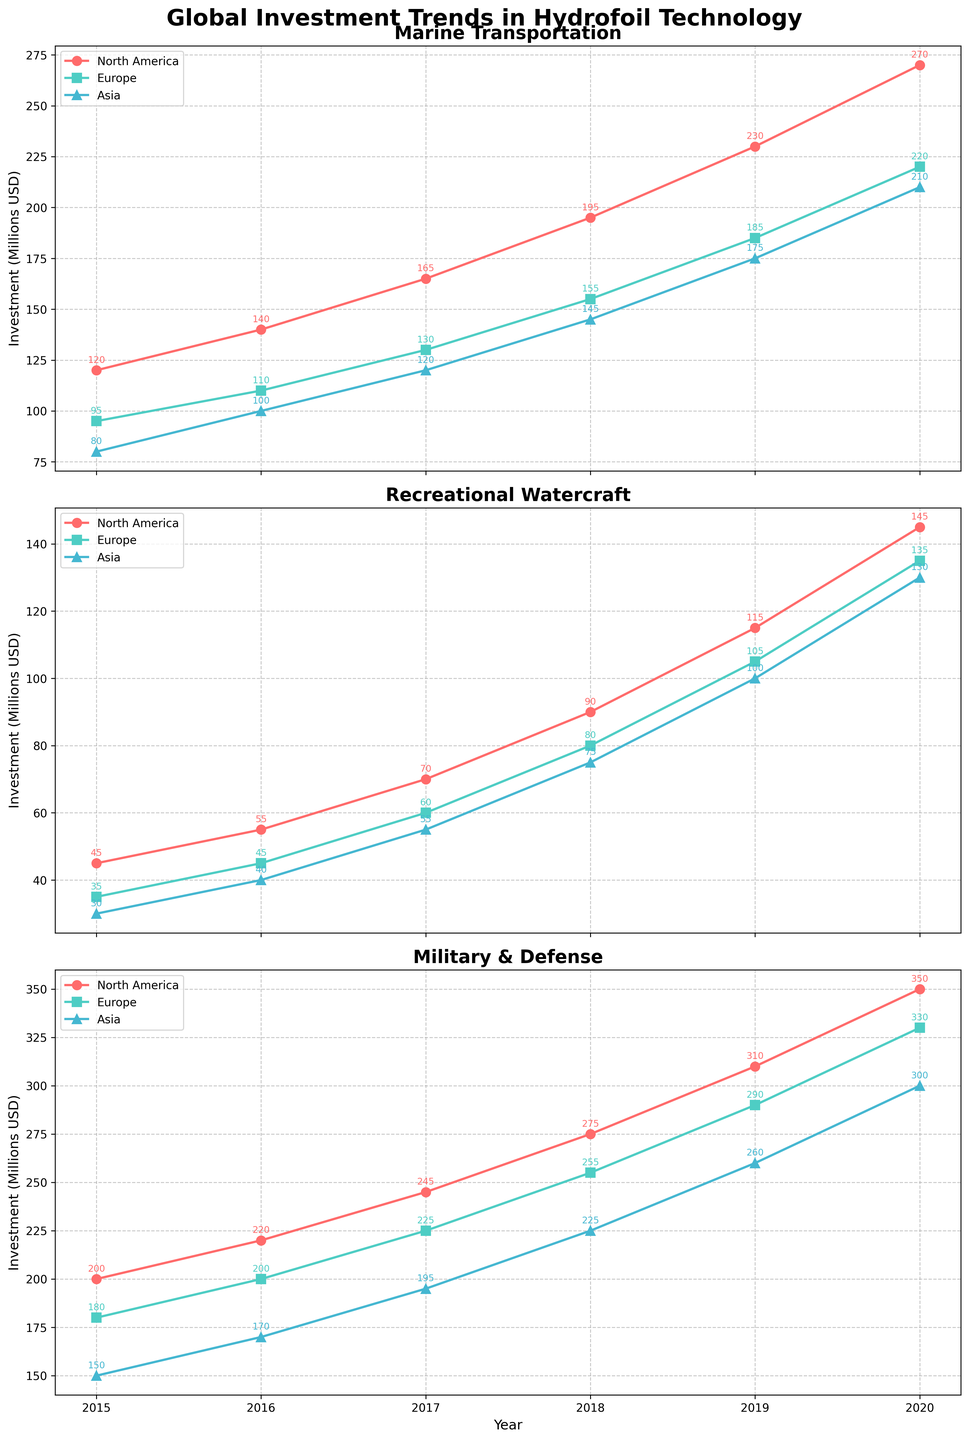What is the total investment in Marine Transportation for North America for all years? First, extract the investment values for North America in the Marine Transportation sector for all years. Sum these values: 120 (2015) + 140 (2016) + 165 (2017) + 195 (2018) + 230 (2019) + 270 (2020) = 1120 million USD.
Answer: 1120 million USD Which sector in Europe saw the highest investment in the year 2020? Identify the investment values for Europe in the year 2020 across all sectors: Marine Transportation (220), Recreational Watercraft (135), Military & Defense (330). The highest value among these is 330 million USD for the Military & Defense sector.
Answer: Military & Defense What was the trend in the Recreational Watercraft investment in Asia from 2015 to 2020? Analyze the yearly investment values for Asia in the Recreational Watercraft sector: 2015 (30), 2016 (40), 2017 (55), 2018 (75), 2019 (100), 2020 (130). The values show an increasing trend over the years.
Answer: Increasing By how much did the investment in Military & Defense for North America increase from 2015 to 2020? Compare the investment values for Military & Defense in North America for the years 2015 (200) and 2020 (350). The increase is calculated as 350 - 200 = 150 million USD.
Answer: 150 million USD Which region had the lowest investment in Recreational Watercraft in 2017? Examine the investment values for Recreational Watercraft in 2017 across all regions: North America (70), Europe (60), Asia (55). The lowest investment is in Asia with 55 million USD.
Answer: Asia What is the average annual investment in Military & Defense for Europe from 2015 to 2020? Extract the annual investment values in Military & Defense for Europe: 2015 (180), 2016 (200), 2017 (225), 2018 (255), 2019 (290), 2020 (330). Calculate the average: (180 + 200 + 225 + 255 + 290 + 330) / 6 = 246.67 million USD.
Answer: 246.67 million USD Which year did North America see the highest investment in Marine Transportation, and how much was it? Identify the investment values for Marine Transportation in North America across all years: 2015 (120), 2016 (140), 2017 (165), 2018 (195), 2019 (230), 2020 (270). The highest investment was in 2020 amounting to 270 million USD.
Answer: 2020, 270 million USD How does the investment in Marine Transportation in Asia in 2020 compare to that in Europe in the same year? Compare the investment values for Marine Transportation in Asia (210) and Europe (220) in 2020. Since 210 < 220, Asia's investment is lower than Europe's.
Answer: Asia's investment is lower What was the percentage increase in the investment in Military & Defense in Asia from 2017 to 2020? Compute the percentage increase from 2017 (195) to 2020 (300) as follows: [(300 - 195) / 195] * 100 = 53.85%.
Answer: 53.85% What is the total investment in Recreational Watercraft globally in 2019? Sum the investment values for Recreational Watercraft in 2019 across all regions: North America (115), Europe (105), Asia (100). Total is 115 + 105 + 100 = 320 million USD.
Answer: 320 million USD 